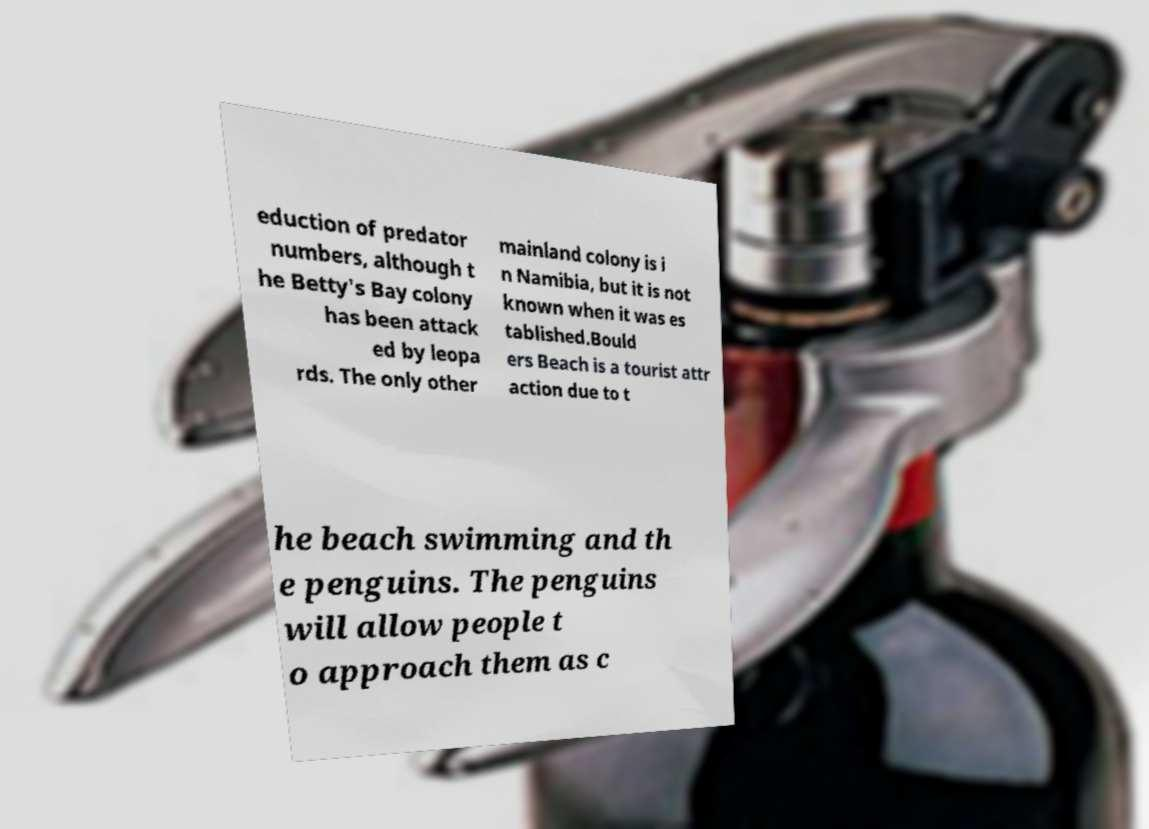Can you accurately transcribe the text from the provided image for me? eduction of predator numbers, although t he Betty's Bay colony has been attack ed by leopa rds. The only other mainland colony is i n Namibia, but it is not known when it was es tablished.Bould ers Beach is a tourist attr action due to t he beach swimming and th e penguins. The penguins will allow people t o approach them as c 